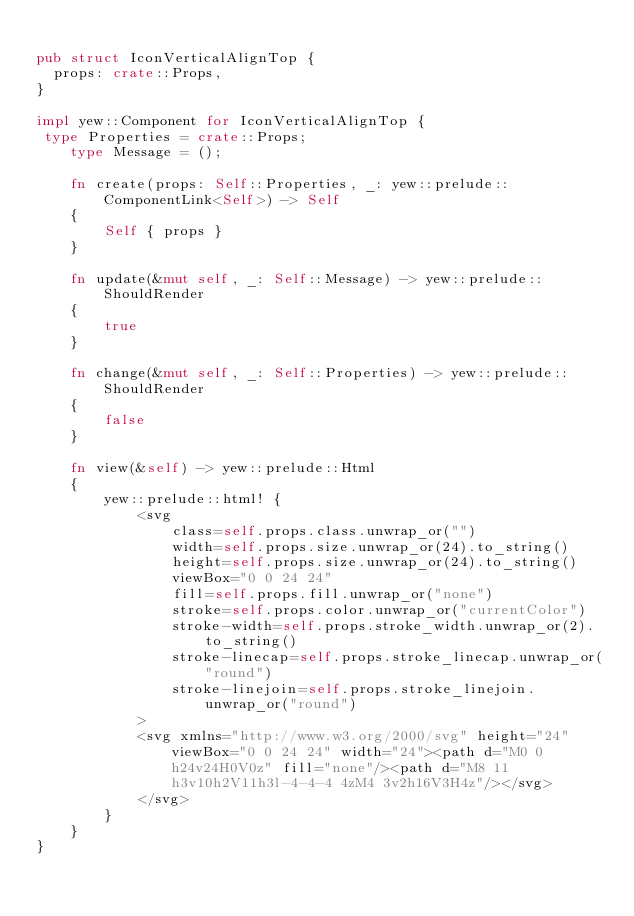<code> <loc_0><loc_0><loc_500><loc_500><_Rust_>
pub struct IconVerticalAlignTop {
  props: crate::Props,
}

impl yew::Component for IconVerticalAlignTop {
 type Properties = crate::Props;
    type Message = ();

    fn create(props: Self::Properties, _: yew::prelude::ComponentLink<Self>) -> Self
    {
        Self { props }
    }

    fn update(&mut self, _: Self::Message) -> yew::prelude::ShouldRender
    {
        true
    }

    fn change(&mut self, _: Self::Properties) -> yew::prelude::ShouldRender
    {
        false
    }

    fn view(&self) -> yew::prelude::Html
    {
        yew::prelude::html! {
            <svg
                class=self.props.class.unwrap_or("")
                width=self.props.size.unwrap_or(24).to_string()
                height=self.props.size.unwrap_or(24).to_string()
                viewBox="0 0 24 24"
                fill=self.props.fill.unwrap_or("none")
                stroke=self.props.color.unwrap_or("currentColor")
                stroke-width=self.props.stroke_width.unwrap_or(2).to_string()
                stroke-linecap=self.props.stroke_linecap.unwrap_or("round")
                stroke-linejoin=self.props.stroke_linejoin.unwrap_or("round")
            >
            <svg xmlns="http://www.w3.org/2000/svg" height="24" viewBox="0 0 24 24" width="24"><path d="M0 0h24v24H0V0z" fill="none"/><path d="M8 11h3v10h2V11h3l-4-4-4 4zM4 3v2h16V3H4z"/></svg>
            </svg>
        }
    }
}


</code> 